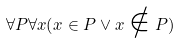<formula> <loc_0><loc_0><loc_500><loc_500>\forall P \forall x ( x \in P \vee x \notin P )</formula> 